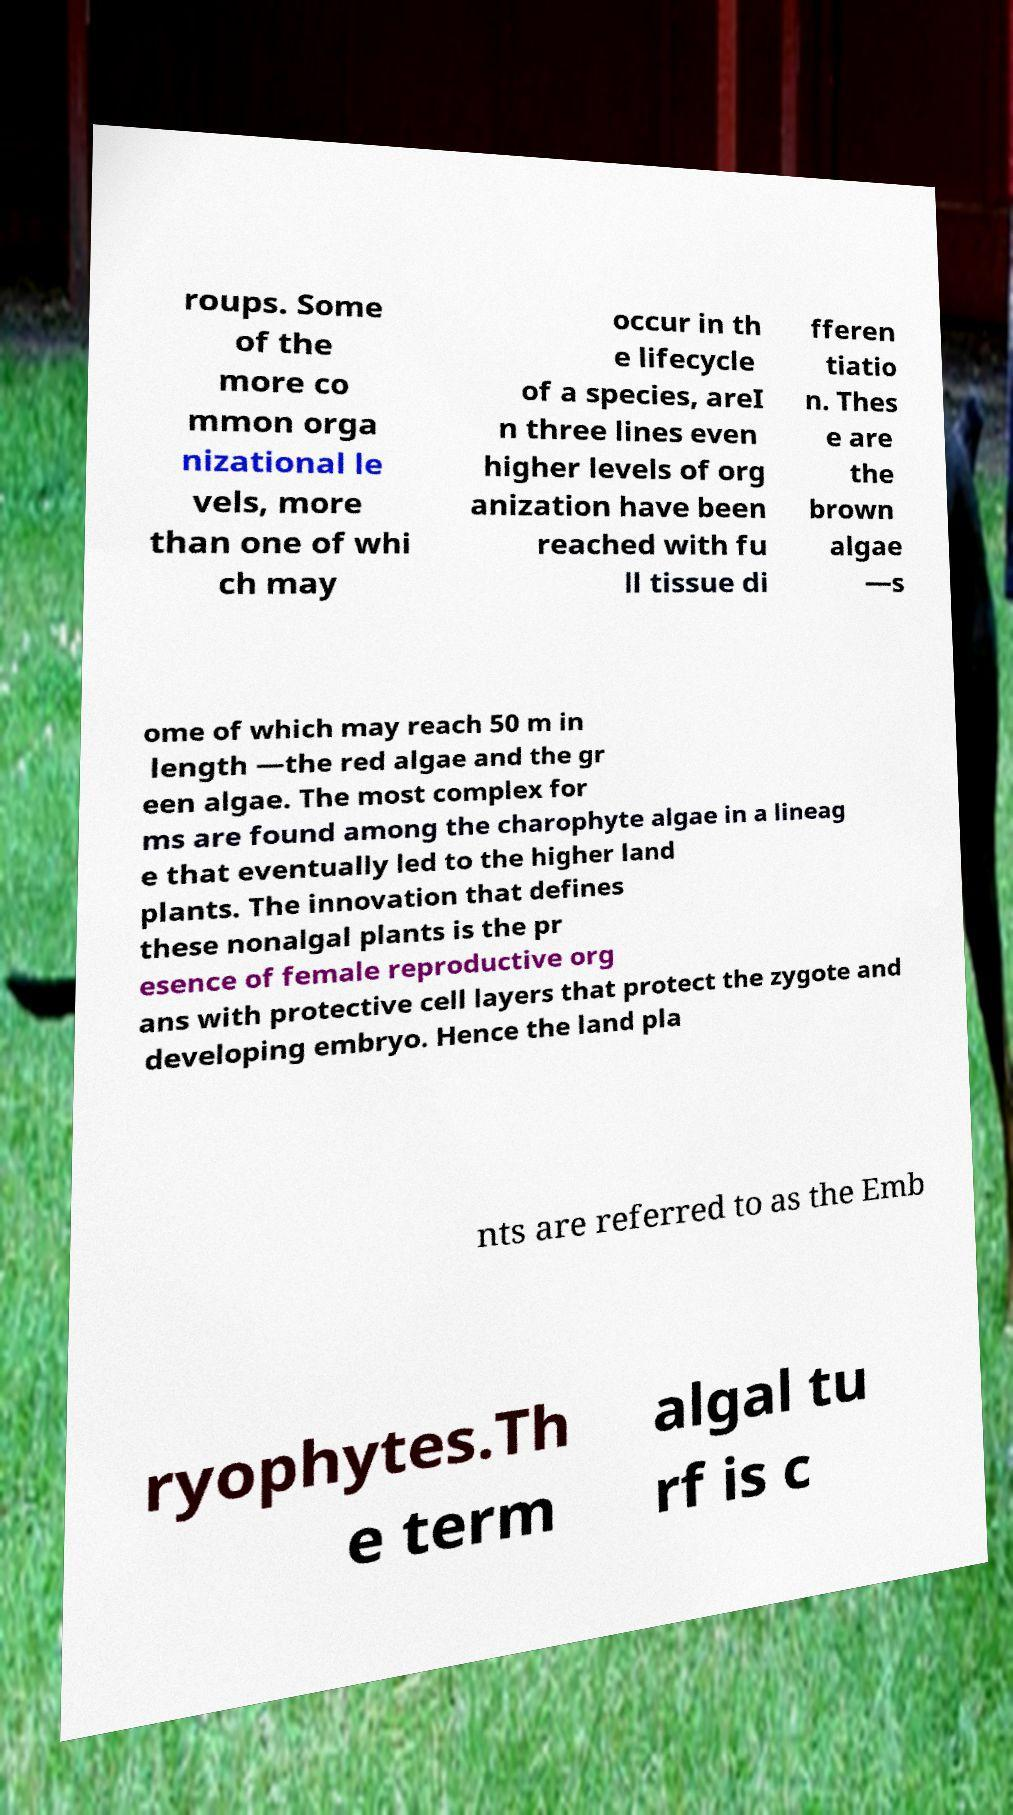Can you read and provide the text displayed in the image?This photo seems to have some interesting text. Can you extract and type it out for me? roups. Some of the more co mmon orga nizational le vels, more than one of whi ch may occur in th e lifecycle of a species, areI n three lines even higher levels of org anization have been reached with fu ll tissue di fferen tiatio n. Thes e are the brown algae —s ome of which may reach 50 m in length —the red algae and the gr een algae. The most complex for ms are found among the charophyte algae in a lineag e that eventually led to the higher land plants. The innovation that defines these nonalgal plants is the pr esence of female reproductive org ans with protective cell layers that protect the zygote and developing embryo. Hence the land pla nts are referred to as the Emb ryophytes.Th e term algal tu rf is c 